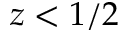Convert formula to latex. <formula><loc_0><loc_0><loc_500><loc_500>z < 1 / 2</formula> 